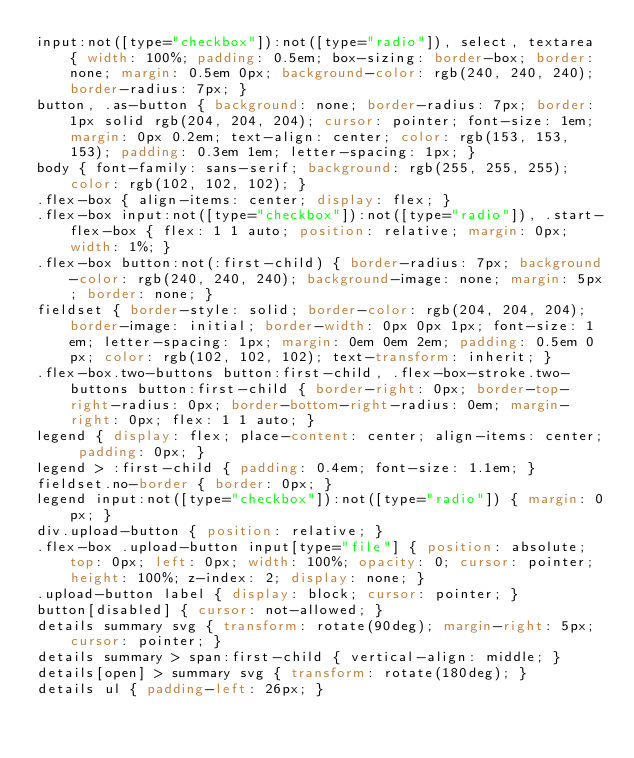Convert code to text. <code><loc_0><loc_0><loc_500><loc_500><_CSS_>input:not([type="checkbox"]):not([type="radio"]), select, textarea { width: 100%; padding: 0.5em; box-sizing: border-box; border: none; margin: 0.5em 0px; background-color: rgb(240, 240, 240); border-radius: 7px; }
button, .as-button { background: none; border-radius: 7px; border: 1px solid rgb(204, 204, 204); cursor: pointer; font-size: 1em; margin: 0px 0.2em; text-align: center; color: rgb(153, 153, 153); padding: 0.3em 1em; letter-spacing: 1px; }
body { font-family: sans-serif; background: rgb(255, 255, 255); color: rgb(102, 102, 102); }
.flex-box { align-items: center; display: flex; }
.flex-box input:not([type="checkbox"]):not([type="radio"]), .start-flex-box { flex: 1 1 auto; position: relative; margin: 0px; width: 1%; }
.flex-box button:not(:first-child) { border-radius: 7px; background-color: rgb(240, 240, 240); background-image: none; margin: 5px; border: none; }
fieldset { border-style: solid; border-color: rgb(204, 204, 204); border-image: initial; border-width: 0px 0px 1px; font-size: 1em; letter-spacing: 1px; margin: 0em 0em 2em; padding: 0.5em 0px; color: rgb(102, 102, 102); text-transform: inherit; }
.flex-box.two-buttons button:first-child, .flex-box-stroke.two-buttons button:first-child { border-right: 0px; border-top-right-radius: 0px; border-bottom-right-radius: 0em; margin-right: 0px; flex: 1 1 auto; }
legend { display: flex; place-content: center; align-items: center; padding: 0px; }
legend > :first-child { padding: 0.4em; font-size: 1.1em; }
fieldset.no-border { border: 0px; }
legend input:not([type="checkbox"]):not([type="radio"]) { margin: 0px; }
div.upload-button { position: relative; }
.flex-box .upload-button input[type="file"] { position: absolute; top: 0px; left: 0px; width: 100%; opacity: 0; cursor: pointer; height: 100%; z-index: 2; display: none; }
.upload-button label { display: block; cursor: pointer; }
button[disabled] { cursor: not-allowed; }
details summary svg { transform: rotate(90deg); margin-right: 5px; cursor: pointer; }
details summary > span:first-child { vertical-align: middle; }
details[open] > summary svg { transform: rotate(180deg); }
details ul { padding-left: 26px; }</code> 